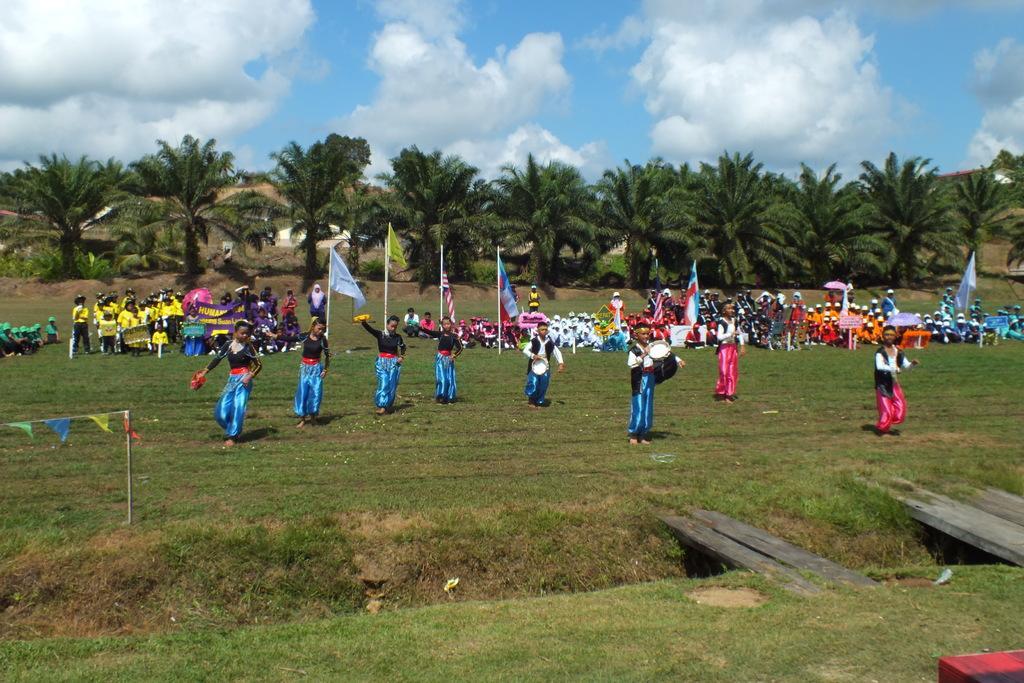How would you summarize this image in a sentence or two? In this image there are group of persons dancing, sitting and standing. In the front there is grass on the ground and the center there are persons dancing. In the background there are flags and there are persons standing, sitting and in the background there are trees and the sky is cloudy. 